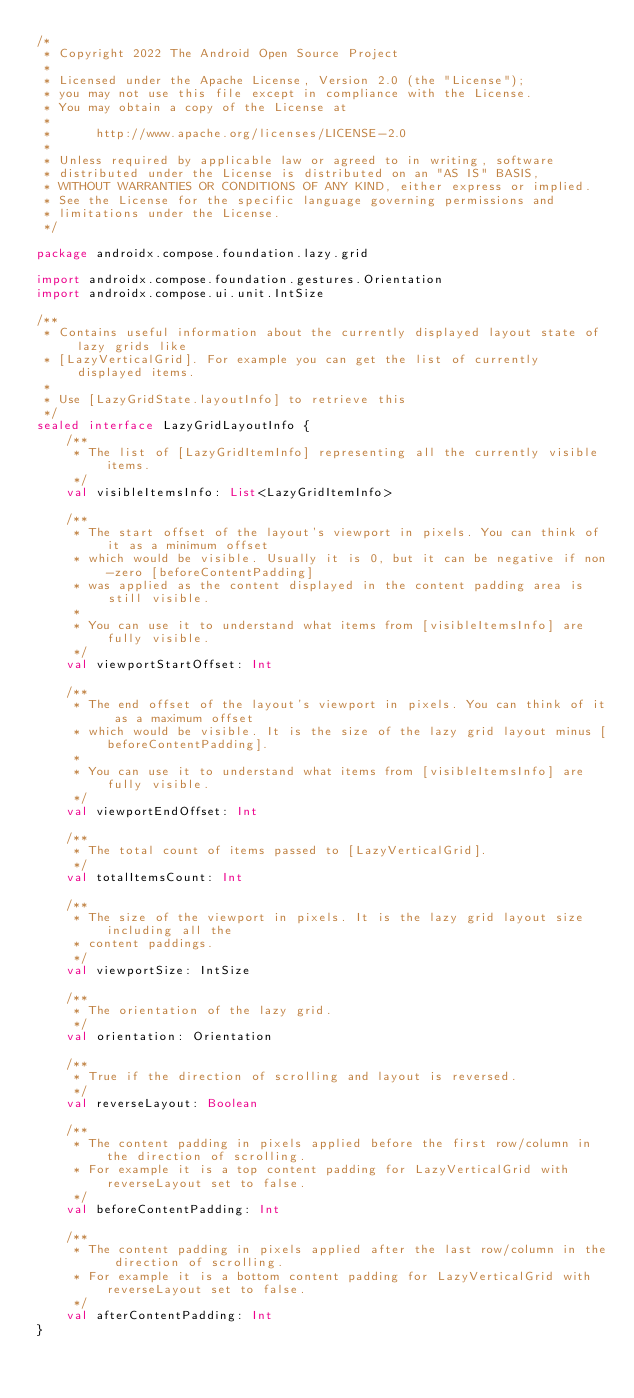<code> <loc_0><loc_0><loc_500><loc_500><_Kotlin_>/*
 * Copyright 2022 The Android Open Source Project
 *
 * Licensed under the Apache License, Version 2.0 (the "License");
 * you may not use this file except in compliance with the License.
 * You may obtain a copy of the License at
 *
 *      http://www.apache.org/licenses/LICENSE-2.0
 *
 * Unless required by applicable law or agreed to in writing, software
 * distributed under the License is distributed on an "AS IS" BASIS,
 * WITHOUT WARRANTIES OR CONDITIONS OF ANY KIND, either express or implied.
 * See the License for the specific language governing permissions and
 * limitations under the License.
 */

package androidx.compose.foundation.lazy.grid

import androidx.compose.foundation.gestures.Orientation
import androidx.compose.ui.unit.IntSize

/**
 * Contains useful information about the currently displayed layout state of lazy grids like
 * [LazyVerticalGrid]. For example you can get the list of currently displayed items.
 *
 * Use [LazyGridState.layoutInfo] to retrieve this
 */
sealed interface LazyGridLayoutInfo {
    /**
     * The list of [LazyGridItemInfo] representing all the currently visible items.
     */
    val visibleItemsInfo: List<LazyGridItemInfo>

    /**
     * The start offset of the layout's viewport in pixels. You can think of it as a minimum offset
     * which would be visible. Usually it is 0, but it can be negative if non-zero [beforeContentPadding]
     * was applied as the content displayed in the content padding area is still visible.
     *
     * You can use it to understand what items from [visibleItemsInfo] are fully visible.
     */
    val viewportStartOffset: Int

    /**
     * The end offset of the layout's viewport in pixels. You can think of it as a maximum offset
     * which would be visible. It is the size of the lazy grid layout minus [beforeContentPadding].
     *
     * You can use it to understand what items from [visibleItemsInfo] are fully visible.
     */
    val viewportEndOffset: Int

    /**
     * The total count of items passed to [LazyVerticalGrid].
     */
    val totalItemsCount: Int

    /**
     * The size of the viewport in pixels. It is the lazy grid layout size including all the
     * content paddings.
     */
    val viewportSize: IntSize

    /**
     * The orientation of the lazy grid.
     */
    val orientation: Orientation

    /**
     * True if the direction of scrolling and layout is reversed.
     */
    val reverseLayout: Boolean

    /**
     * The content padding in pixels applied before the first row/column in the direction of scrolling.
     * For example it is a top content padding for LazyVerticalGrid with reverseLayout set to false.
     */
    val beforeContentPadding: Int

    /**
     * The content padding in pixels applied after the last row/column in the direction of scrolling.
     * For example it is a bottom content padding for LazyVerticalGrid with reverseLayout set to false.
     */
    val afterContentPadding: Int
}
</code> 